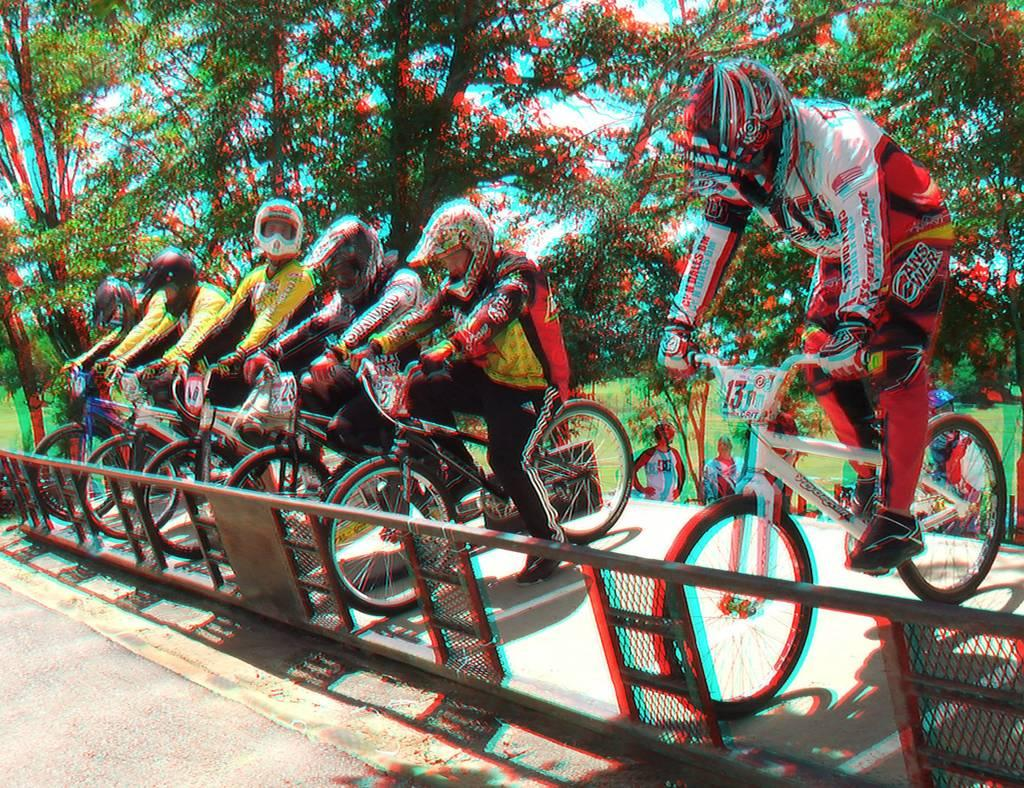What type of vegetation is present in the image? There are trees and grass in the image. What are the people in the image doing? The people are sitting on bicycles near a railing. What safety precautions are the people taking in the image? The people are wearing helmets. What type of footwear are the people wearing in the image? The people are wearing shoes. What activity are the people preparing for in the image? They are ready for a race. What smell can be detected from the trees in the image? There is no information about the smell of the trees in the image. Is there a box present in the image? There is no mention of a box in the image. 